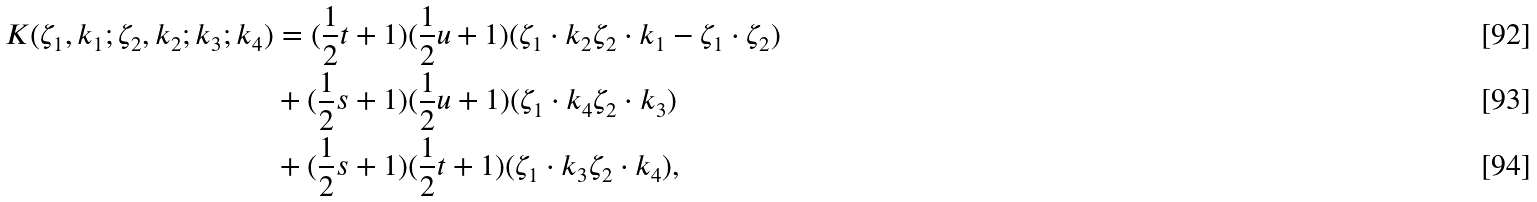Convert formula to latex. <formula><loc_0><loc_0><loc_500><loc_500>K ( \zeta _ { 1 } , k _ { 1 } ; \zeta _ { 2 } , k _ { 2 } ; k _ { 3 } ; k _ { 4 } ) & = ( \frac { 1 } { 2 } t + 1 ) ( \frac { 1 } { 2 } u + 1 ) ( \zeta _ { 1 } \cdot k _ { 2 } \zeta _ { 2 } \cdot k _ { 1 } - \zeta _ { 1 } \cdot \zeta _ { 2 } ) \\ & + ( \frac { 1 } { 2 } s + 1 ) ( \frac { 1 } { 2 } u + 1 ) ( \zeta _ { 1 } \cdot k _ { 4 } \zeta _ { 2 } \cdot k _ { 3 } ) \\ & + ( \frac { 1 } { 2 } s + 1 ) ( \frac { 1 } { 2 } t + 1 ) ( \zeta _ { 1 } \cdot k _ { 3 } \zeta _ { 2 } \cdot k _ { 4 } ) ,</formula> 